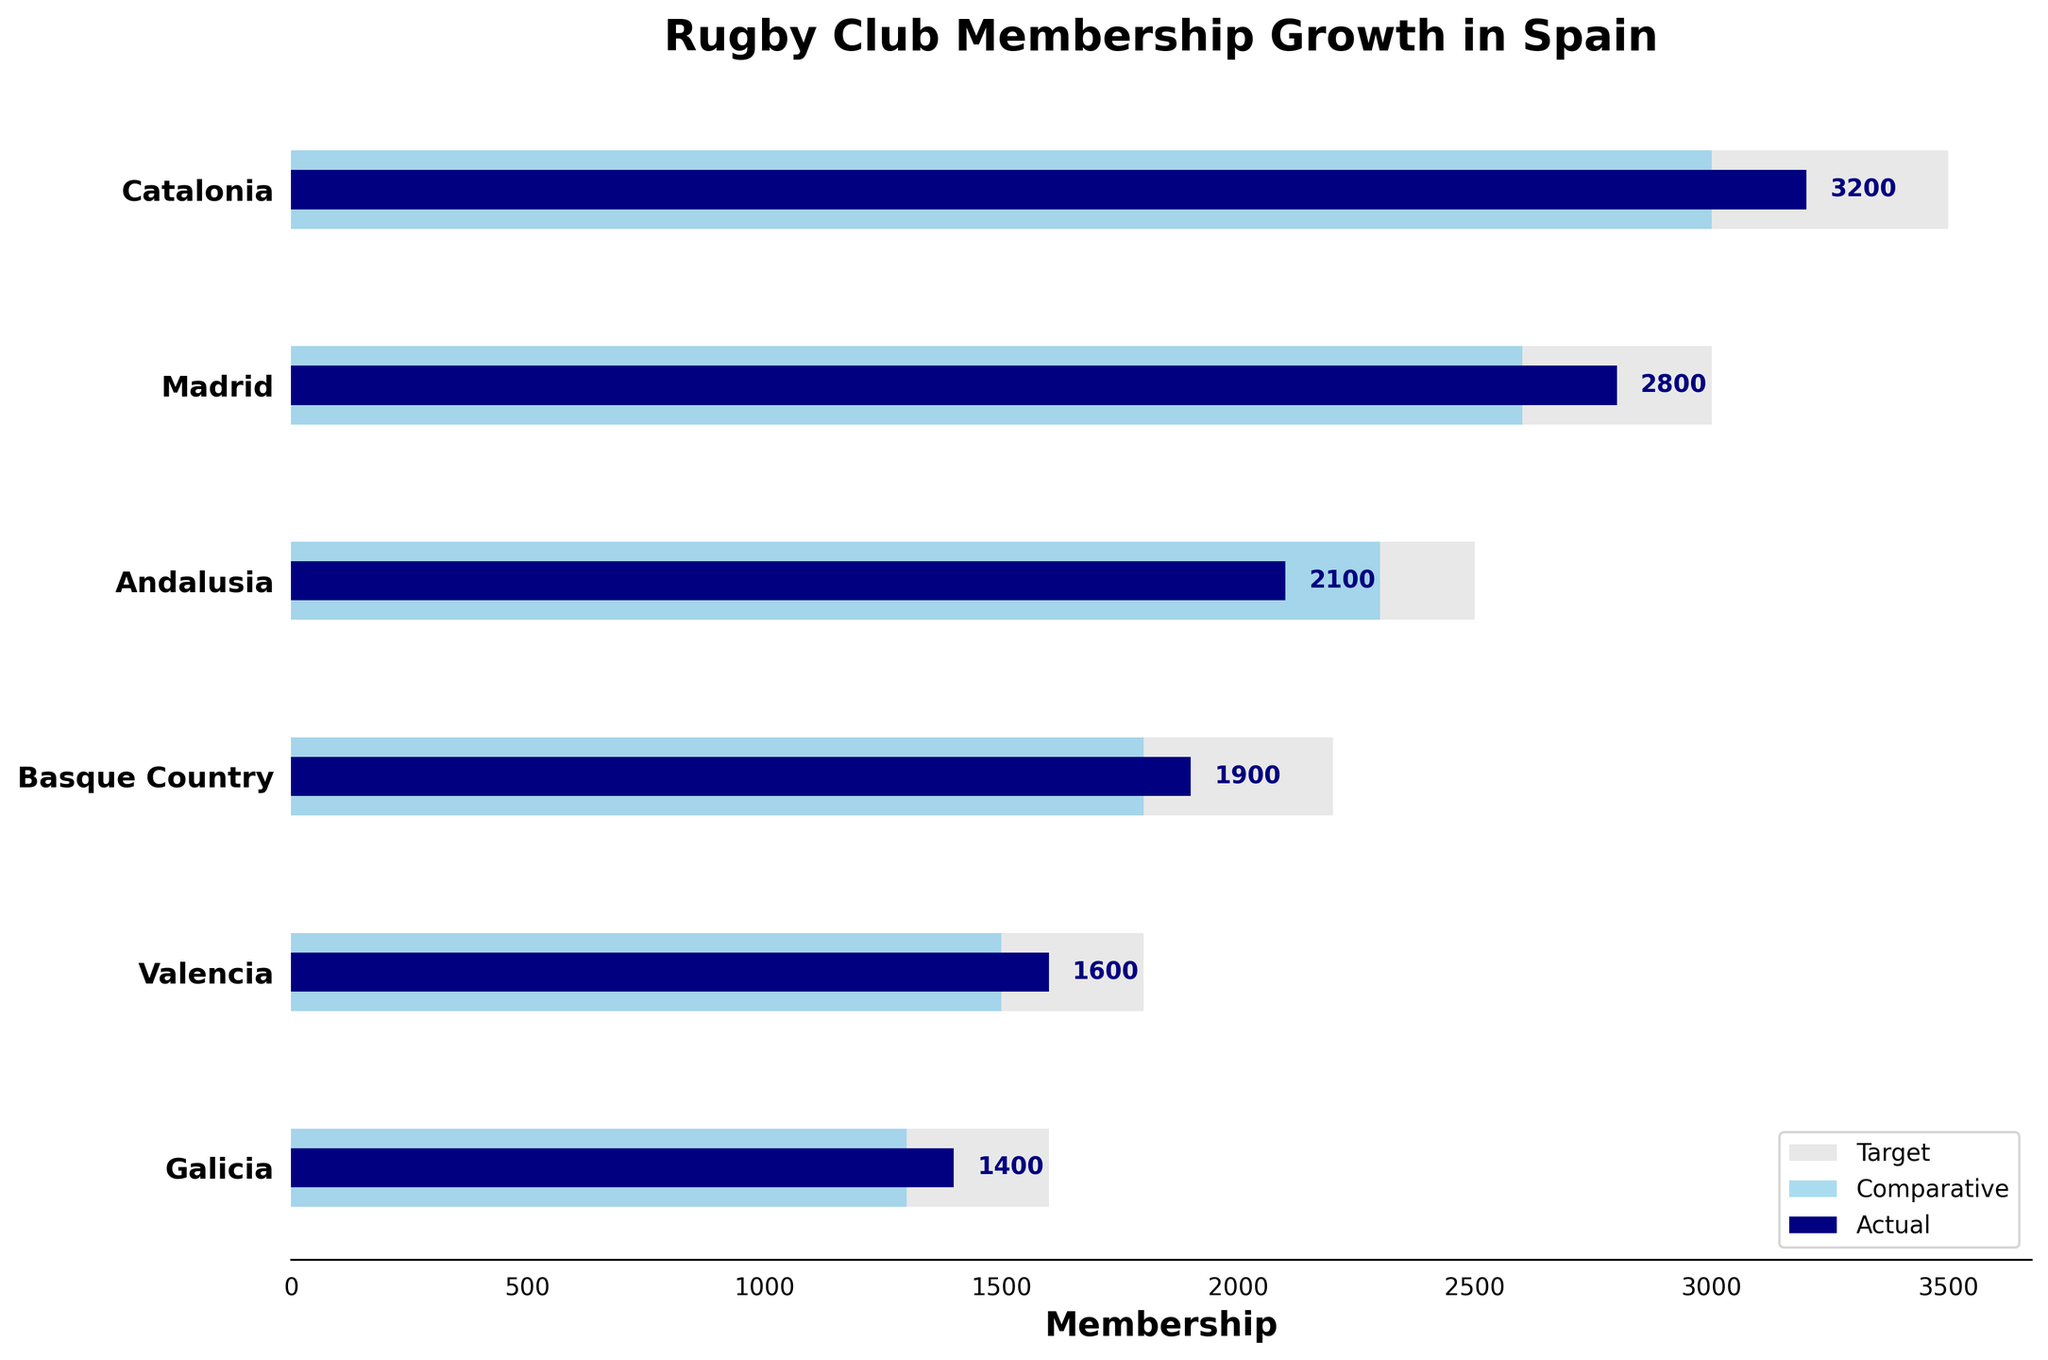What is the title of the chart? The title of the chart is displayed at the top and reads "Rugby Club Membership Growth in Spain".
Answer: Rugby Club Membership Growth in Spain Which region has the highest actual membership? Looking at the 'Actual' values represented by the dark navy bars, Catalonia has the highest value.
Answer: Catalonia How does Madrid's actual membership compare to its target membership? Madrid's actual membership is represented by a shorter dark navy bar compared to its target, depicted by the longer light gray bar. Specifically, Madrid's actual membership is 2800, and the target is 3000.
Answer: Lower What color represents the comparative membership values? The comparative membership values are shown with sky blue bars.
Answer: Sky blue How much greater is Catalonia's actual membership compared to Basque Country's actual membership? Catalonia's actual membership is 3200, and Basque Country's actual membership is 1900. The difference is 3200 - 1900.
Answer: 1300 What is the average target membership across all regions? Sum all the target values: 3500 + 3000 + 2500 + 2200 + 1800 + 1600 = 14600. Then divide by the number of regions (6) to find the average.
Answer: 2433.33 Which region has the actual membership closest to the comparative membership? Compare the 'Actual' and 'Comparative' values for each region and find the smallest difference. Madrid has an actual membership of 2800 and a comparative membership of 2600, which is a difference of 200, the closest among all regions.
Answer: Madrid What is the total actual membership for all regions combined? Sum all the actual membership values: 3200 + 2800 + 2100 + 1900 + 1600 + 1400. 3200 + 2800 + 2100 + 1900 + 1600 + 1400 = 13000
Answer: 13000 How does Valencia's actual membership compare to its target membership? Valencia's actual membership is 1600, whereas its target membership is 1800. The actual membership is less than the target membership.
Answer: Less Which regions have an actual membership that surpasses the comparative membership? Compare the 'Actual' and 'Comparative' membership values for each region. Catalonia (3200 > 3000), Madrid (2800 > 2600), and Basque Country (1900 > 1800).
Answer: Catalonia, Madrid, Basque Country 